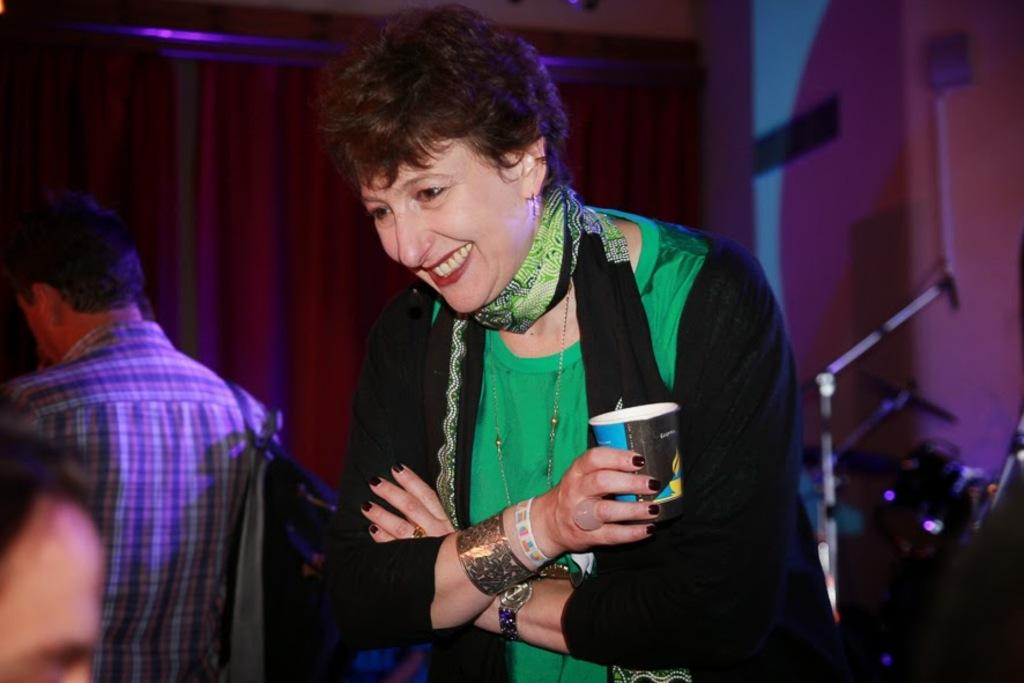What is the lady in the image wearing on her head? The lady is wearing a scarf. What type of accessory is the lady wearing on her wrist? The lady is wearing bangles. What is the lady holding in her hand? The lady is holding a cup. What is the man in the image holding? The man is holding a bag. What can be seen in the background of the image? There are curtains in the background. How would you describe the overall clarity of the image? The image appears blurred. How many sheep are visible in the image? There are no sheep present in the image. What type of pest can be seen crawling on the man's shoulder in the image? There are no pests visible in the image; it is a lady and a man, and no pests are mentioned in the facts. 